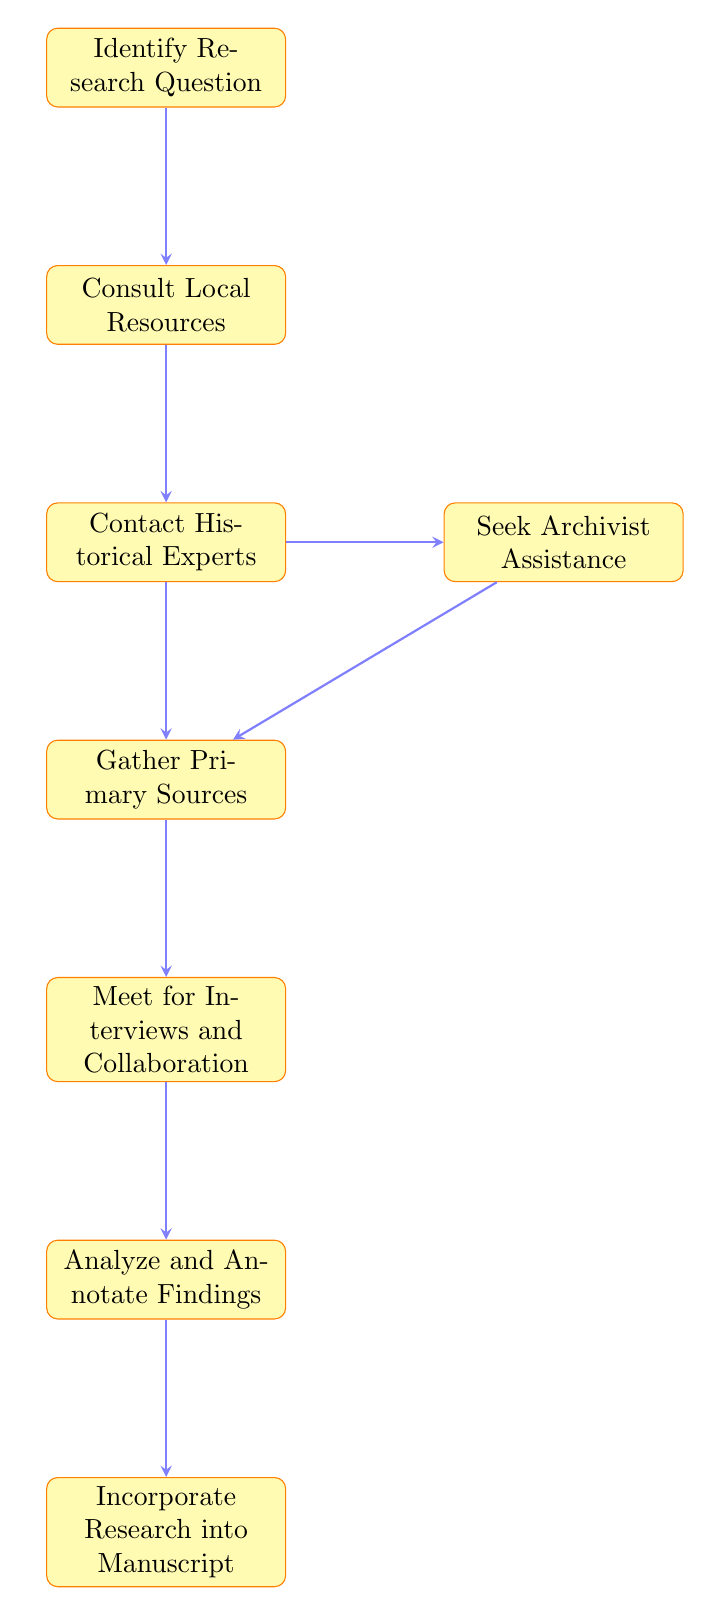What is the first step in the communication process? The first step is “Identify Research Question,” which begins the flow of the communication process with historical experts and archivists.
Answer: Identify Research Question How many main nodes are in the diagram? The diagram contains eight main nodes, each representing a step in the communication process from start to finish.
Answer: Eight Which step follows “Analyze and Annotate Findings”? The step that follows “Analyze and Annotate Findings” is “Incorporate Research into Manuscript,” which indicates the final stage of integrating research.
Answer: Incorporate Research into Manuscript What two nodes are directly connected? The nodes “Experts” and “Archivists” are directly connected by an arrow, indicating a collaborative relationship in the process.
Answer: Experts and Archivists How does one gather primary sources? To gather primary sources, one goes through the node “Gather Primary Sources” after consulting both historical experts and archivists, implying a combination of resources and expertise.
Answer: Gather Primary Sources What step involves meeting experts for deeper insights? The step involving meeting experts for deeper insights is “Meet for Interviews and Collaboration.” This emphasizes engaging with experts face-to-face or virtually.
Answer: Meet for Interviews and Collaboration What action should be taken after seeking archivist assistance? After seeking archivist assistance, the action to take is to “Gather Primary Sources.” This step shows the progression towards collecting valuable materials for historical research.
Answer: Gather Primary Sources What node is at the bottom of the flow chart? The node at the bottom of the flow chart is “Incorporate Research into Manuscript,” which is the concluding step of the process.
Answer: Incorporate Research into Manuscript 